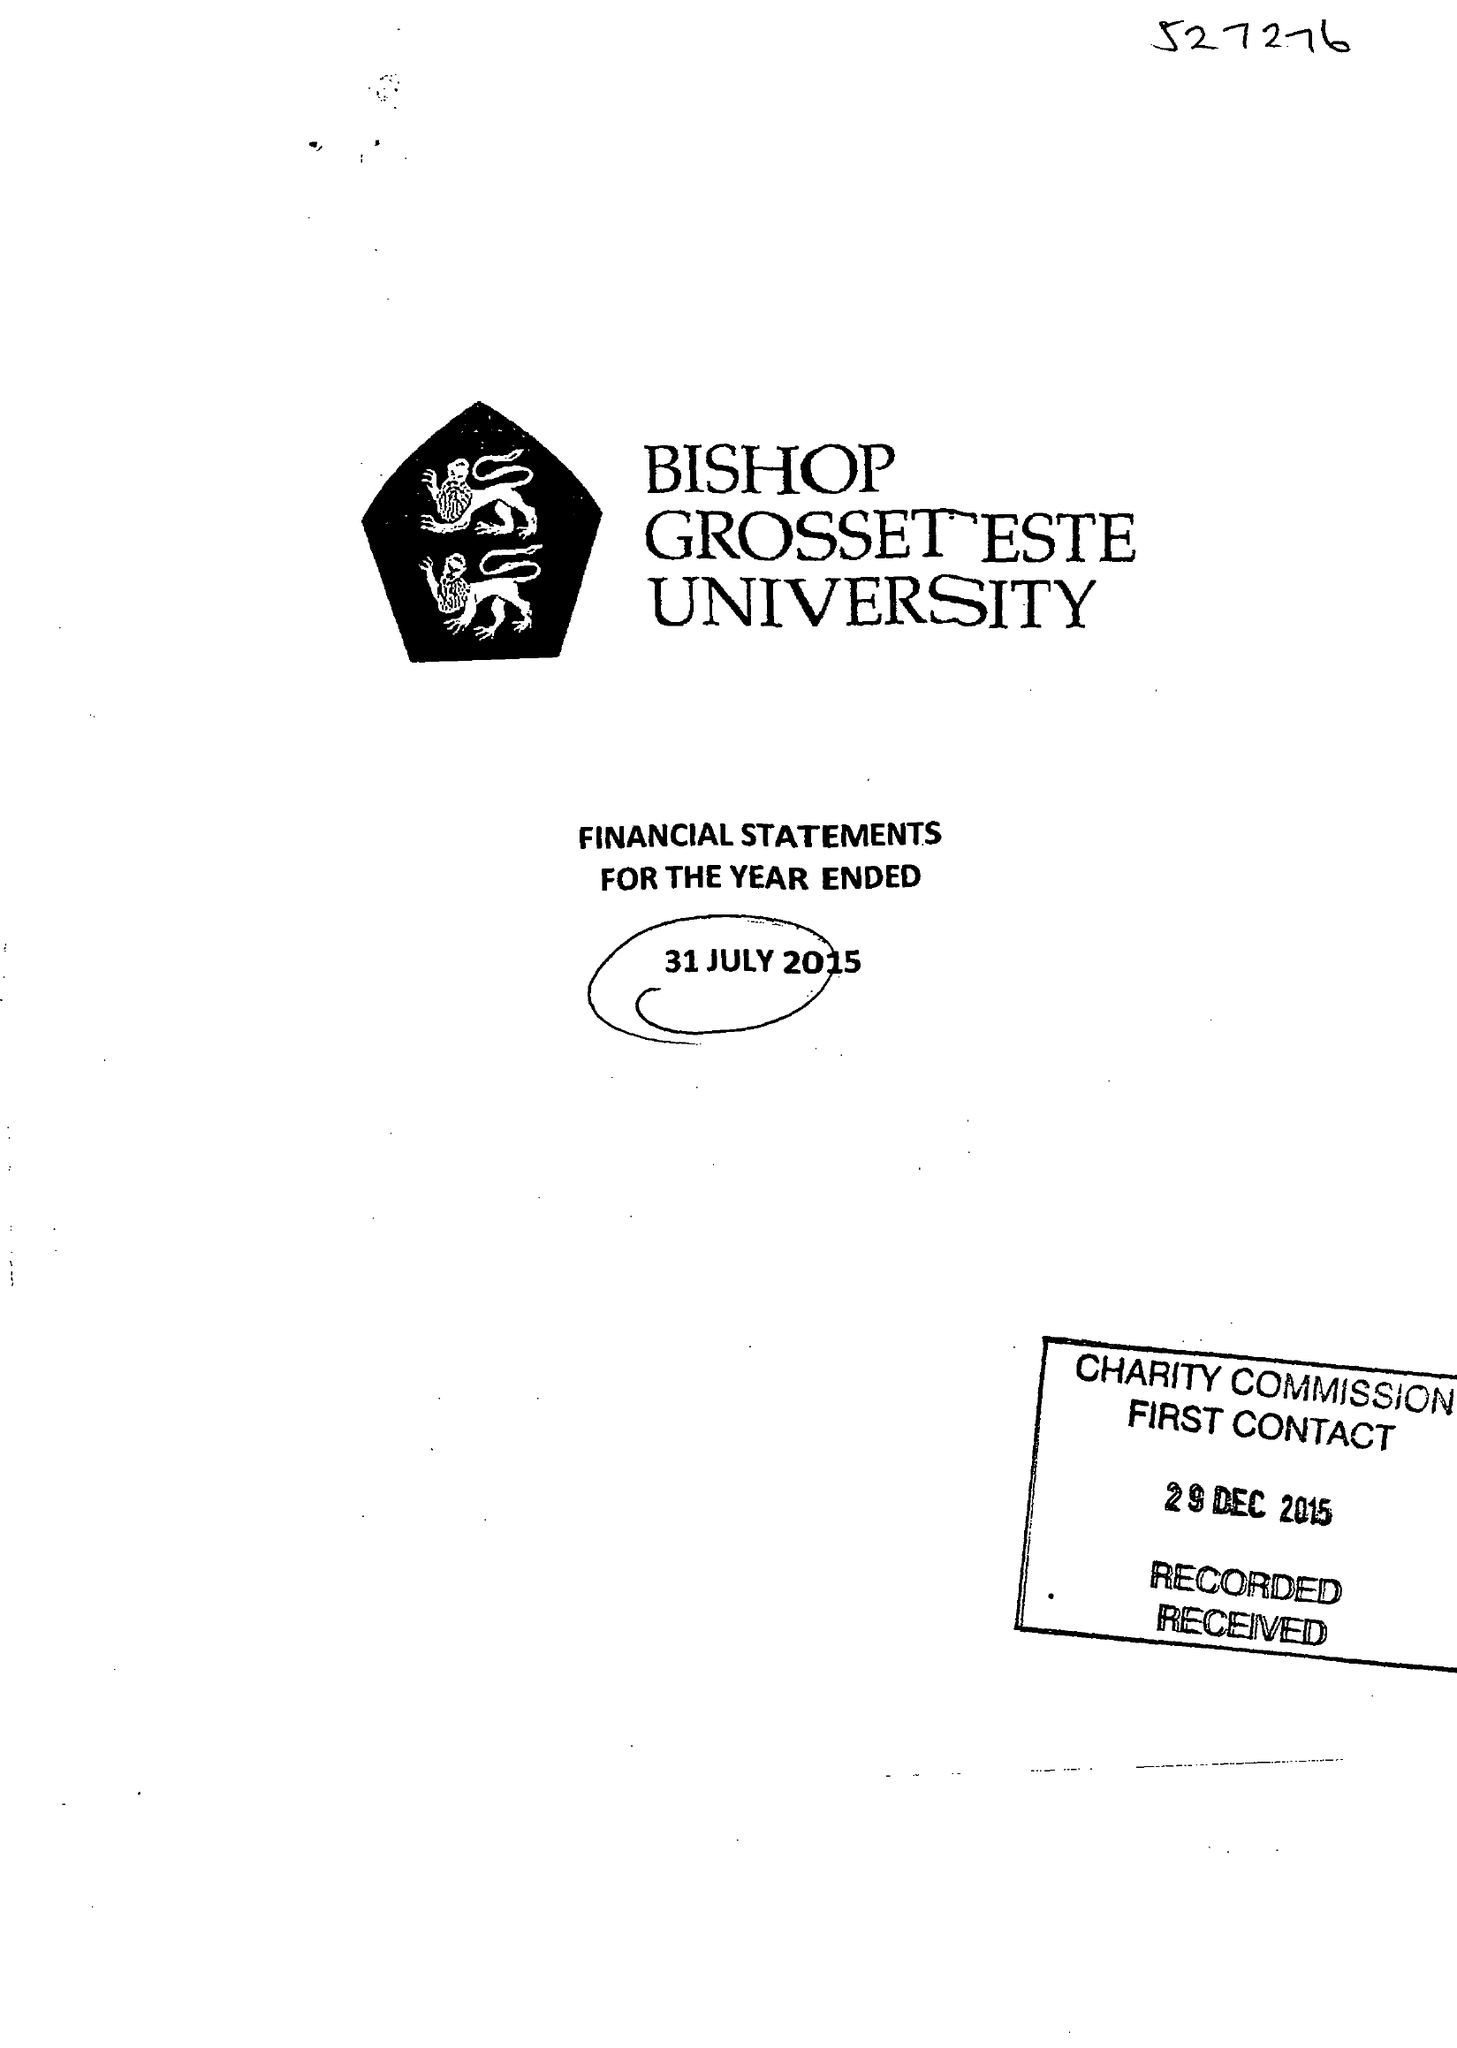What is the value for the income_annually_in_british_pounds?
Answer the question using a single word or phrase. 20102154.00 